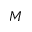<formula> <loc_0><loc_0><loc_500><loc_500>M</formula> 